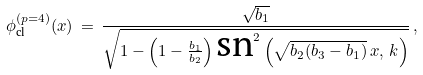Convert formula to latex. <formula><loc_0><loc_0><loc_500><loc_500>\phi _ { \text {cl} } ^ { ( p = 4 ) } ( x ) \, = \, \frac { \sqrt { b _ { 1 } } } { \sqrt { 1 - \left ( 1 - \frac { b _ { 1 } } { b _ { 2 } } \right ) \text {sn} ^ { 2 } \left ( \sqrt { b _ { 2 } ( b _ { 3 } - b _ { 1 } ) } \, x , \, k \right ) } } \, ,</formula> 